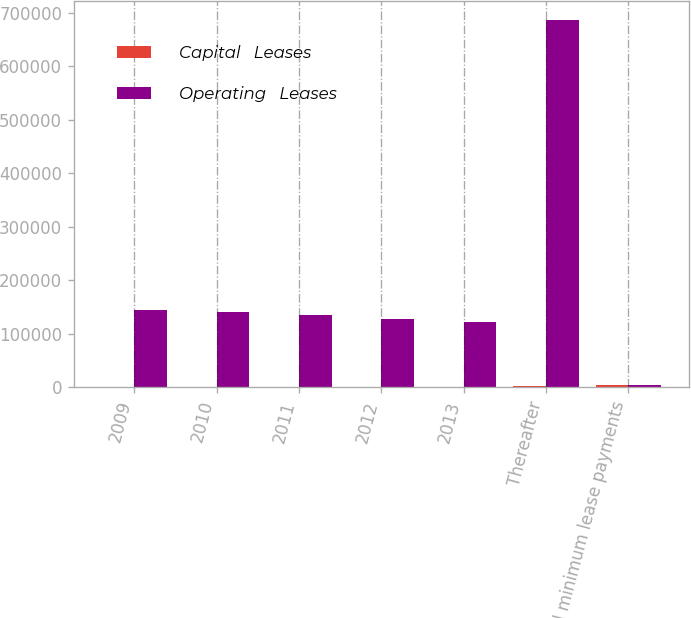Convert chart. <chart><loc_0><loc_0><loc_500><loc_500><stacked_bar_chart><ecel><fcel>2009<fcel>2010<fcel>2011<fcel>2012<fcel>2013<fcel>Thereafter<fcel>Total minimum lease payments<nl><fcel>Capital   Leases<fcel>720<fcel>520<fcel>206<fcel>146<fcel>146<fcel>2218<fcel>3956<nl><fcel>Operating   Leases<fcel>145109<fcel>140716<fcel>135431<fcel>128546<fcel>122287<fcel>687438<fcel>3956<nl></chart> 